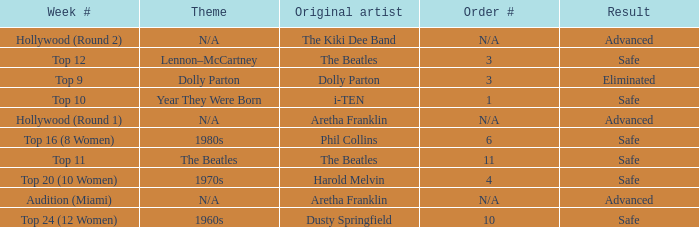What is the original artist that has 11 as the order number? The Beatles. 